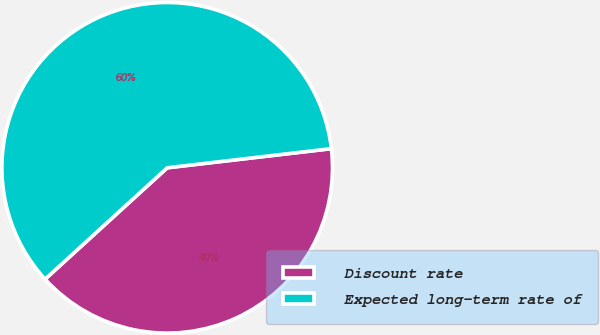Convert chart. <chart><loc_0><loc_0><loc_500><loc_500><pie_chart><fcel>Discount rate<fcel>Expected long-term rate of<nl><fcel>40.08%<fcel>59.92%<nl></chart> 